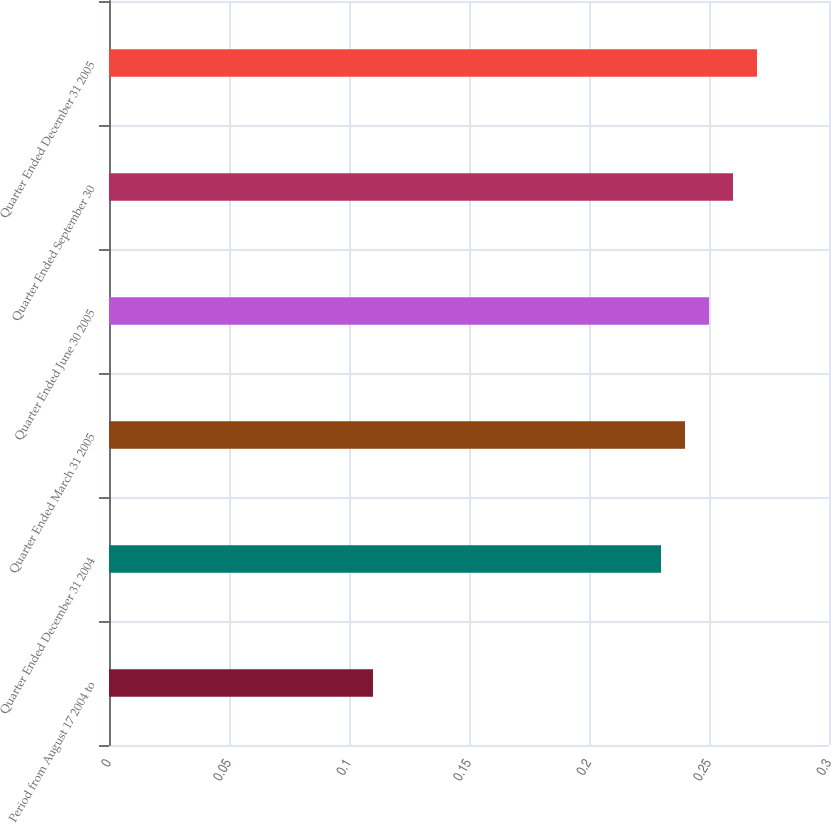Convert chart. <chart><loc_0><loc_0><loc_500><loc_500><bar_chart><fcel>Period from August 17 2004 to<fcel>Quarter Ended December 31 2004<fcel>Quarter Ended March 31 2005<fcel>Quarter Ended June 30 2005<fcel>Quarter Ended September 30<fcel>Quarter Ended December 31 2005<nl><fcel>0.11<fcel>0.23<fcel>0.24<fcel>0.25<fcel>0.26<fcel>0.27<nl></chart> 